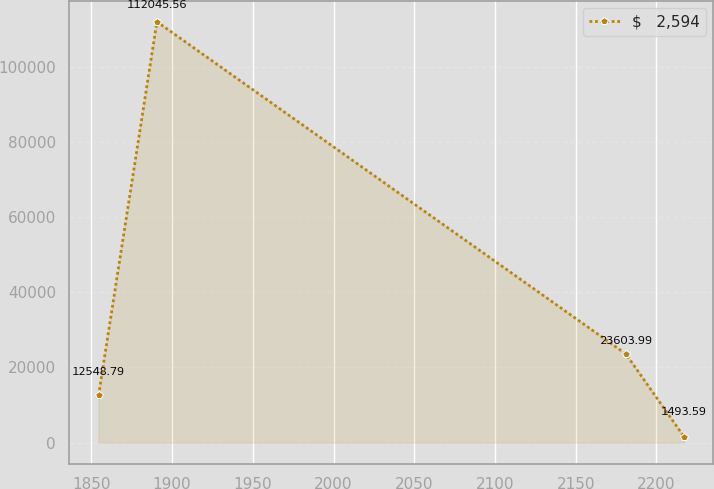Convert chart to OTSL. <chart><loc_0><loc_0><loc_500><loc_500><line_chart><ecel><fcel>$   2,594<nl><fcel>1854.44<fcel>12548.8<nl><fcel>1890.59<fcel>112046<nl><fcel>2181.02<fcel>23604<nl><fcel>2217.17<fcel>1493.59<nl></chart> 